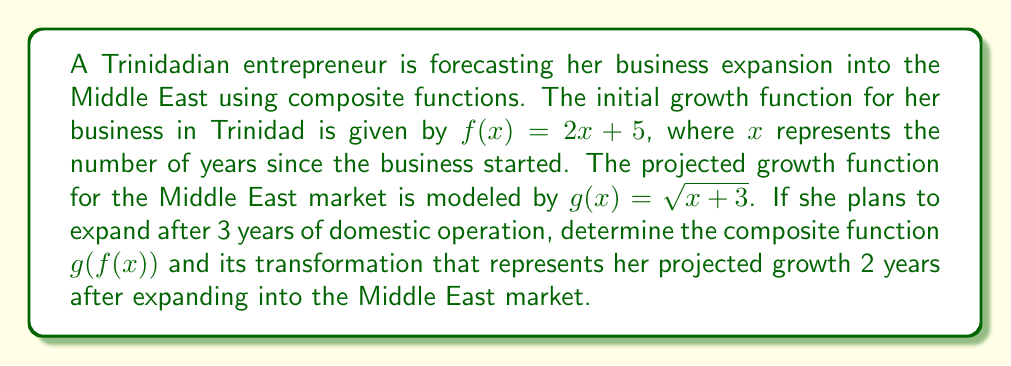Solve this math problem. Let's approach this step-by-step:

1) First, we need to find the composite function $g(f(x))$:
   
   $f(x) = 2x + 5$
   $g(x) = \sqrt{x + 3}$
   
   $g(f(x)) = g(2x + 5) = \sqrt{(2x + 5) + 3} = \sqrt{2x + 8}$

2) Now, we have the composite function $g(f(x)) = \sqrt{2x + 8}$

3) The entrepreneur plans to expand after 3 years of domestic operation. This means we need to shift the function 3 units to the left. We can do this by replacing $x$ with $(x + 3)$:

   $g(f(x)) = \sqrt{2(x + 3) + 8} = \sqrt{2x + 6 + 8} = \sqrt{2x + 14}$

4) To represent the growth 2 years after expanding into the Middle East, we need to evaluate this function at $x = 2$:

   $g(f(2)) = \sqrt{2(2) + 14} = \sqrt{4 + 14} = \sqrt{18} = 3\sqrt{2}$

Therefore, the transformed composite function that represents the projected growth 2 years after expanding into the Middle East market is $\sqrt{2x + 14}$, and its value at that point is $3\sqrt{2}$.
Answer: The transformed composite function is $g(f(x)) = \sqrt{2x + 14}$, and the projected growth 2 years after expanding into the Middle East market is $3\sqrt{2}$. 